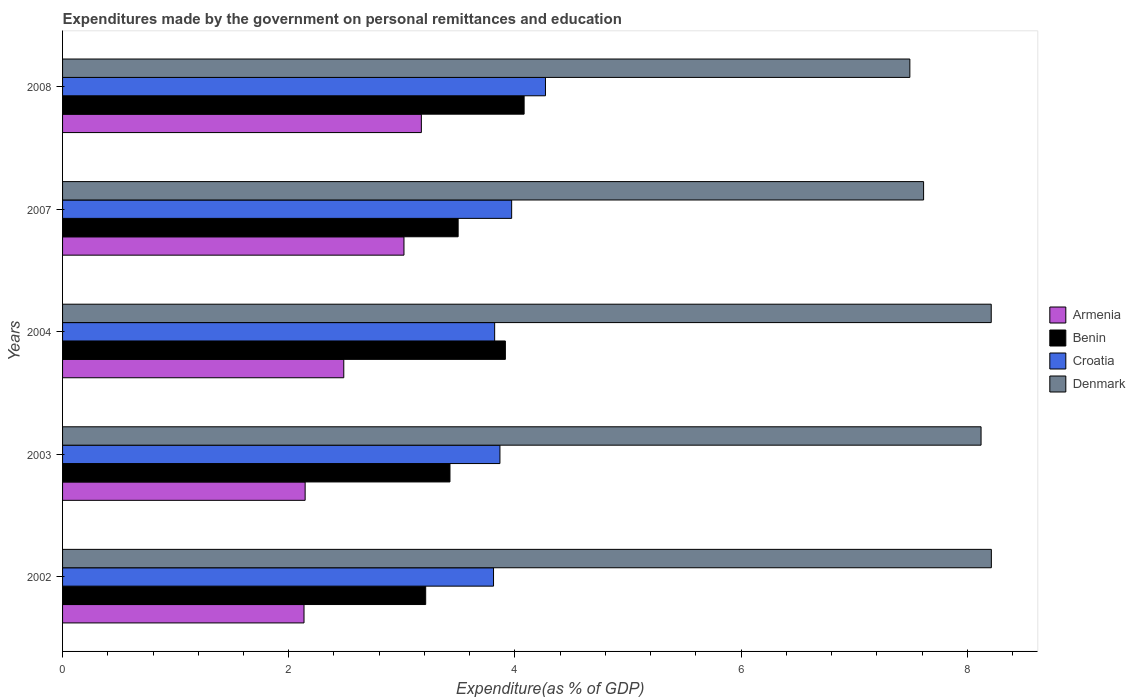How many different coloured bars are there?
Provide a succinct answer. 4. How many bars are there on the 5th tick from the top?
Ensure brevity in your answer.  4. What is the label of the 1st group of bars from the top?
Ensure brevity in your answer.  2008. In how many cases, is the number of bars for a given year not equal to the number of legend labels?
Your answer should be very brief. 0. What is the expenditures made by the government on personal remittances and education in Denmark in 2002?
Provide a short and direct response. 8.21. Across all years, what is the maximum expenditures made by the government on personal remittances and education in Armenia?
Offer a very short reply. 3.17. Across all years, what is the minimum expenditures made by the government on personal remittances and education in Denmark?
Provide a succinct answer. 7.49. In which year was the expenditures made by the government on personal remittances and education in Armenia maximum?
Offer a terse response. 2008. What is the total expenditures made by the government on personal remittances and education in Croatia in the graph?
Your answer should be compact. 19.74. What is the difference between the expenditures made by the government on personal remittances and education in Benin in 2002 and that in 2007?
Offer a very short reply. -0.29. What is the difference between the expenditures made by the government on personal remittances and education in Benin in 2007 and the expenditures made by the government on personal remittances and education in Denmark in 2002?
Your answer should be very brief. -4.72. What is the average expenditures made by the government on personal remittances and education in Croatia per year?
Your answer should be compact. 3.95. In the year 2002, what is the difference between the expenditures made by the government on personal remittances and education in Croatia and expenditures made by the government on personal remittances and education in Benin?
Your answer should be compact. 0.6. In how many years, is the expenditures made by the government on personal remittances and education in Denmark greater than 6 %?
Offer a very short reply. 5. What is the ratio of the expenditures made by the government on personal remittances and education in Denmark in 2003 to that in 2008?
Keep it short and to the point. 1.08. Is the difference between the expenditures made by the government on personal remittances and education in Croatia in 2003 and 2008 greater than the difference between the expenditures made by the government on personal remittances and education in Benin in 2003 and 2008?
Offer a terse response. Yes. What is the difference between the highest and the second highest expenditures made by the government on personal remittances and education in Benin?
Your answer should be very brief. 0.17. What is the difference between the highest and the lowest expenditures made by the government on personal remittances and education in Armenia?
Offer a very short reply. 1.04. Is the sum of the expenditures made by the government on personal remittances and education in Denmark in 2003 and 2007 greater than the maximum expenditures made by the government on personal remittances and education in Armenia across all years?
Offer a terse response. Yes. What does the 2nd bar from the top in 2004 represents?
Give a very brief answer. Croatia. What does the 4th bar from the bottom in 2008 represents?
Provide a succinct answer. Denmark. Is it the case that in every year, the sum of the expenditures made by the government on personal remittances and education in Croatia and expenditures made by the government on personal remittances and education in Benin is greater than the expenditures made by the government on personal remittances and education in Armenia?
Ensure brevity in your answer.  Yes. Are all the bars in the graph horizontal?
Provide a succinct answer. Yes. What is the difference between two consecutive major ticks on the X-axis?
Your answer should be compact. 2. Where does the legend appear in the graph?
Keep it short and to the point. Center right. How are the legend labels stacked?
Provide a succinct answer. Vertical. What is the title of the graph?
Your answer should be very brief. Expenditures made by the government on personal remittances and education. What is the label or title of the X-axis?
Your response must be concise. Expenditure(as % of GDP). What is the Expenditure(as % of GDP) of Armenia in 2002?
Ensure brevity in your answer.  2.14. What is the Expenditure(as % of GDP) of Benin in 2002?
Give a very brief answer. 3.21. What is the Expenditure(as % of GDP) of Croatia in 2002?
Give a very brief answer. 3.81. What is the Expenditure(as % of GDP) in Denmark in 2002?
Make the answer very short. 8.21. What is the Expenditure(as % of GDP) in Armenia in 2003?
Your response must be concise. 2.15. What is the Expenditure(as % of GDP) of Benin in 2003?
Offer a very short reply. 3.43. What is the Expenditure(as % of GDP) of Croatia in 2003?
Keep it short and to the point. 3.87. What is the Expenditure(as % of GDP) in Denmark in 2003?
Make the answer very short. 8.12. What is the Expenditure(as % of GDP) of Armenia in 2004?
Offer a very short reply. 2.49. What is the Expenditure(as % of GDP) in Benin in 2004?
Ensure brevity in your answer.  3.92. What is the Expenditure(as % of GDP) in Croatia in 2004?
Offer a terse response. 3.82. What is the Expenditure(as % of GDP) of Denmark in 2004?
Ensure brevity in your answer.  8.21. What is the Expenditure(as % of GDP) in Armenia in 2007?
Your response must be concise. 3.02. What is the Expenditure(as % of GDP) of Benin in 2007?
Give a very brief answer. 3.5. What is the Expenditure(as % of GDP) in Croatia in 2007?
Ensure brevity in your answer.  3.97. What is the Expenditure(as % of GDP) of Denmark in 2007?
Ensure brevity in your answer.  7.61. What is the Expenditure(as % of GDP) of Armenia in 2008?
Make the answer very short. 3.17. What is the Expenditure(as % of GDP) of Benin in 2008?
Your answer should be very brief. 4.08. What is the Expenditure(as % of GDP) in Croatia in 2008?
Give a very brief answer. 4.27. What is the Expenditure(as % of GDP) in Denmark in 2008?
Offer a very short reply. 7.49. Across all years, what is the maximum Expenditure(as % of GDP) in Armenia?
Ensure brevity in your answer.  3.17. Across all years, what is the maximum Expenditure(as % of GDP) of Benin?
Give a very brief answer. 4.08. Across all years, what is the maximum Expenditure(as % of GDP) of Croatia?
Your response must be concise. 4.27. Across all years, what is the maximum Expenditure(as % of GDP) of Denmark?
Provide a short and direct response. 8.21. Across all years, what is the minimum Expenditure(as % of GDP) of Armenia?
Offer a terse response. 2.14. Across all years, what is the minimum Expenditure(as % of GDP) in Benin?
Make the answer very short. 3.21. Across all years, what is the minimum Expenditure(as % of GDP) of Croatia?
Provide a succinct answer. 3.81. Across all years, what is the minimum Expenditure(as % of GDP) of Denmark?
Ensure brevity in your answer.  7.49. What is the total Expenditure(as % of GDP) of Armenia in the graph?
Ensure brevity in your answer.  12.96. What is the total Expenditure(as % of GDP) in Benin in the graph?
Offer a terse response. 18.13. What is the total Expenditure(as % of GDP) of Croatia in the graph?
Give a very brief answer. 19.74. What is the total Expenditure(as % of GDP) in Denmark in the graph?
Keep it short and to the point. 39.65. What is the difference between the Expenditure(as % of GDP) in Armenia in 2002 and that in 2003?
Provide a short and direct response. -0.01. What is the difference between the Expenditure(as % of GDP) in Benin in 2002 and that in 2003?
Your answer should be compact. -0.21. What is the difference between the Expenditure(as % of GDP) in Croatia in 2002 and that in 2003?
Provide a short and direct response. -0.06. What is the difference between the Expenditure(as % of GDP) in Denmark in 2002 and that in 2003?
Offer a terse response. 0.09. What is the difference between the Expenditure(as % of GDP) of Armenia in 2002 and that in 2004?
Make the answer very short. -0.35. What is the difference between the Expenditure(as % of GDP) in Benin in 2002 and that in 2004?
Make the answer very short. -0.7. What is the difference between the Expenditure(as % of GDP) in Croatia in 2002 and that in 2004?
Your answer should be very brief. -0.01. What is the difference between the Expenditure(as % of GDP) of Denmark in 2002 and that in 2004?
Give a very brief answer. 0. What is the difference between the Expenditure(as % of GDP) of Armenia in 2002 and that in 2007?
Offer a very short reply. -0.88. What is the difference between the Expenditure(as % of GDP) of Benin in 2002 and that in 2007?
Provide a short and direct response. -0.29. What is the difference between the Expenditure(as % of GDP) of Croatia in 2002 and that in 2007?
Provide a short and direct response. -0.16. What is the difference between the Expenditure(as % of GDP) of Denmark in 2002 and that in 2007?
Provide a succinct answer. 0.6. What is the difference between the Expenditure(as % of GDP) in Armenia in 2002 and that in 2008?
Give a very brief answer. -1.04. What is the difference between the Expenditure(as % of GDP) of Benin in 2002 and that in 2008?
Offer a terse response. -0.87. What is the difference between the Expenditure(as % of GDP) of Croatia in 2002 and that in 2008?
Ensure brevity in your answer.  -0.46. What is the difference between the Expenditure(as % of GDP) of Denmark in 2002 and that in 2008?
Offer a very short reply. 0.72. What is the difference between the Expenditure(as % of GDP) in Armenia in 2003 and that in 2004?
Your answer should be compact. -0.34. What is the difference between the Expenditure(as % of GDP) of Benin in 2003 and that in 2004?
Make the answer very short. -0.49. What is the difference between the Expenditure(as % of GDP) of Croatia in 2003 and that in 2004?
Give a very brief answer. 0.05. What is the difference between the Expenditure(as % of GDP) in Denmark in 2003 and that in 2004?
Your answer should be very brief. -0.09. What is the difference between the Expenditure(as % of GDP) in Armenia in 2003 and that in 2007?
Give a very brief answer. -0.87. What is the difference between the Expenditure(as % of GDP) of Benin in 2003 and that in 2007?
Give a very brief answer. -0.07. What is the difference between the Expenditure(as % of GDP) of Croatia in 2003 and that in 2007?
Your response must be concise. -0.1. What is the difference between the Expenditure(as % of GDP) of Denmark in 2003 and that in 2007?
Your answer should be very brief. 0.51. What is the difference between the Expenditure(as % of GDP) in Armenia in 2003 and that in 2008?
Your answer should be very brief. -1.03. What is the difference between the Expenditure(as % of GDP) in Benin in 2003 and that in 2008?
Offer a very short reply. -0.66. What is the difference between the Expenditure(as % of GDP) in Croatia in 2003 and that in 2008?
Offer a very short reply. -0.4. What is the difference between the Expenditure(as % of GDP) of Denmark in 2003 and that in 2008?
Your answer should be compact. 0.63. What is the difference between the Expenditure(as % of GDP) of Armenia in 2004 and that in 2007?
Your answer should be very brief. -0.53. What is the difference between the Expenditure(as % of GDP) of Benin in 2004 and that in 2007?
Ensure brevity in your answer.  0.42. What is the difference between the Expenditure(as % of GDP) in Croatia in 2004 and that in 2007?
Offer a very short reply. -0.15. What is the difference between the Expenditure(as % of GDP) of Denmark in 2004 and that in 2007?
Your answer should be very brief. 0.6. What is the difference between the Expenditure(as % of GDP) in Armenia in 2004 and that in 2008?
Offer a very short reply. -0.69. What is the difference between the Expenditure(as % of GDP) of Benin in 2004 and that in 2008?
Provide a short and direct response. -0.17. What is the difference between the Expenditure(as % of GDP) in Croatia in 2004 and that in 2008?
Give a very brief answer. -0.45. What is the difference between the Expenditure(as % of GDP) in Denmark in 2004 and that in 2008?
Provide a succinct answer. 0.72. What is the difference between the Expenditure(as % of GDP) in Armenia in 2007 and that in 2008?
Your answer should be compact. -0.15. What is the difference between the Expenditure(as % of GDP) of Benin in 2007 and that in 2008?
Your answer should be very brief. -0.58. What is the difference between the Expenditure(as % of GDP) in Croatia in 2007 and that in 2008?
Make the answer very short. -0.3. What is the difference between the Expenditure(as % of GDP) of Denmark in 2007 and that in 2008?
Make the answer very short. 0.12. What is the difference between the Expenditure(as % of GDP) in Armenia in 2002 and the Expenditure(as % of GDP) in Benin in 2003?
Offer a terse response. -1.29. What is the difference between the Expenditure(as % of GDP) of Armenia in 2002 and the Expenditure(as % of GDP) of Croatia in 2003?
Give a very brief answer. -1.73. What is the difference between the Expenditure(as % of GDP) in Armenia in 2002 and the Expenditure(as % of GDP) in Denmark in 2003?
Offer a terse response. -5.99. What is the difference between the Expenditure(as % of GDP) in Benin in 2002 and the Expenditure(as % of GDP) in Croatia in 2003?
Your answer should be very brief. -0.66. What is the difference between the Expenditure(as % of GDP) in Benin in 2002 and the Expenditure(as % of GDP) in Denmark in 2003?
Keep it short and to the point. -4.91. What is the difference between the Expenditure(as % of GDP) in Croatia in 2002 and the Expenditure(as % of GDP) in Denmark in 2003?
Your response must be concise. -4.31. What is the difference between the Expenditure(as % of GDP) of Armenia in 2002 and the Expenditure(as % of GDP) of Benin in 2004?
Give a very brief answer. -1.78. What is the difference between the Expenditure(as % of GDP) in Armenia in 2002 and the Expenditure(as % of GDP) in Croatia in 2004?
Keep it short and to the point. -1.69. What is the difference between the Expenditure(as % of GDP) of Armenia in 2002 and the Expenditure(as % of GDP) of Denmark in 2004?
Make the answer very short. -6.08. What is the difference between the Expenditure(as % of GDP) in Benin in 2002 and the Expenditure(as % of GDP) in Croatia in 2004?
Make the answer very short. -0.61. What is the difference between the Expenditure(as % of GDP) in Benin in 2002 and the Expenditure(as % of GDP) in Denmark in 2004?
Your answer should be compact. -5. What is the difference between the Expenditure(as % of GDP) in Croatia in 2002 and the Expenditure(as % of GDP) in Denmark in 2004?
Your response must be concise. -4.4. What is the difference between the Expenditure(as % of GDP) in Armenia in 2002 and the Expenditure(as % of GDP) in Benin in 2007?
Provide a succinct answer. -1.36. What is the difference between the Expenditure(as % of GDP) of Armenia in 2002 and the Expenditure(as % of GDP) of Croatia in 2007?
Your response must be concise. -1.84. What is the difference between the Expenditure(as % of GDP) of Armenia in 2002 and the Expenditure(as % of GDP) of Denmark in 2007?
Make the answer very short. -5.48. What is the difference between the Expenditure(as % of GDP) in Benin in 2002 and the Expenditure(as % of GDP) in Croatia in 2007?
Offer a terse response. -0.76. What is the difference between the Expenditure(as % of GDP) of Benin in 2002 and the Expenditure(as % of GDP) of Denmark in 2007?
Provide a short and direct response. -4.4. What is the difference between the Expenditure(as % of GDP) in Croatia in 2002 and the Expenditure(as % of GDP) in Denmark in 2007?
Ensure brevity in your answer.  -3.8. What is the difference between the Expenditure(as % of GDP) in Armenia in 2002 and the Expenditure(as % of GDP) in Benin in 2008?
Provide a succinct answer. -1.95. What is the difference between the Expenditure(as % of GDP) of Armenia in 2002 and the Expenditure(as % of GDP) of Croatia in 2008?
Offer a terse response. -2.14. What is the difference between the Expenditure(as % of GDP) in Armenia in 2002 and the Expenditure(as % of GDP) in Denmark in 2008?
Offer a terse response. -5.36. What is the difference between the Expenditure(as % of GDP) in Benin in 2002 and the Expenditure(as % of GDP) in Croatia in 2008?
Your response must be concise. -1.06. What is the difference between the Expenditure(as % of GDP) in Benin in 2002 and the Expenditure(as % of GDP) in Denmark in 2008?
Provide a succinct answer. -4.28. What is the difference between the Expenditure(as % of GDP) of Croatia in 2002 and the Expenditure(as % of GDP) of Denmark in 2008?
Your answer should be very brief. -3.68. What is the difference between the Expenditure(as % of GDP) of Armenia in 2003 and the Expenditure(as % of GDP) of Benin in 2004?
Make the answer very short. -1.77. What is the difference between the Expenditure(as % of GDP) of Armenia in 2003 and the Expenditure(as % of GDP) of Croatia in 2004?
Your answer should be compact. -1.68. What is the difference between the Expenditure(as % of GDP) in Armenia in 2003 and the Expenditure(as % of GDP) in Denmark in 2004?
Keep it short and to the point. -6.07. What is the difference between the Expenditure(as % of GDP) of Benin in 2003 and the Expenditure(as % of GDP) of Croatia in 2004?
Provide a short and direct response. -0.4. What is the difference between the Expenditure(as % of GDP) in Benin in 2003 and the Expenditure(as % of GDP) in Denmark in 2004?
Offer a terse response. -4.79. What is the difference between the Expenditure(as % of GDP) in Croatia in 2003 and the Expenditure(as % of GDP) in Denmark in 2004?
Provide a succinct answer. -4.34. What is the difference between the Expenditure(as % of GDP) in Armenia in 2003 and the Expenditure(as % of GDP) in Benin in 2007?
Keep it short and to the point. -1.35. What is the difference between the Expenditure(as % of GDP) in Armenia in 2003 and the Expenditure(as % of GDP) in Croatia in 2007?
Ensure brevity in your answer.  -1.83. What is the difference between the Expenditure(as % of GDP) in Armenia in 2003 and the Expenditure(as % of GDP) in Denmark in 2007?
Keep it short and to the point. -5.47. What is the difference between the Expenditure(as % of GDP) in Benin in 2003 and the Expenditure(as % of GDP) in Croatia in 2007?
Your answer should be compact. -0.55. What is the difference between the Expenditure(as % of GDP) of Benin in 2003 and the Expenditure(as % of GDP) of Denmark in 2007?
Offer a very short reply. -4.19. What is the difference between the Expenditure(as % of GDP) in Croatia in 2003 and the Expenditure(as % of GDP) in Denmark in 2007?
Provide a short and direct response. -3.75. What is the difference between the Expenditure(as % of GDP) in Armenia in 2003 and the Expenditure(as % of GDP) in Benin in 2008?
Keep it short and to the point. -1.94. What is the difference between the Expenditure(as % of GDP) in Armenia in 2003 and the Expenditure(as % of GDP) in Croatia in 2008?
Make the answer very short. -2.13. What is the difference between the Expenditure(as % of GDP) in Armenia in 2003 and the Expenditure(as % of GDP) in Denmark in 2008?
Keep it short and to the point. -5.35. What is the difference between the Expenditure(as % of GDP) in Benin in 2003 and the Expenditure(as % of GDP) in Croatia in 2008?
Your response must be concise. -0.84. What is the difference between the Expenditure(as % of GDP) of Benin in 2003 and the Expenditure(as % of GDP) of Denmark in 2008?
Give a very brief answer. -4.07. What is the difference between the Expenditure(as % of GDP) in Croatia in 2003 and the Expenditure(as % of GDP) in Denmark in 2008?
Your answer should be compact. -3.62. What is the difference between the Expenditure(as % of GDP) of Armenia in 2004 and the Expenditure(as % of GDP) of Benin in 2007?
Give a very brief answer. -1.01. What is the difference between the Expenditure(as % of GDP) of Armenia in 2004 and the Expenditure(as % of GDP) of Croatia in 2007?
Ensure brevity in your answer.  -1.48. What is the difference between the Expenditure(as % of GDP) of Armenia in 2004 and the Expenditure(as % of GDP) of Denmark in 2007?
Provide a succinct answer. -5.13. What is the difference between the Expenditure(as % of GDP) in Benin in 2004 and the Expenditure(as % of GDP) in Croatia in 2007?
Keep it short and to the point. -0.06. What is the difference between the Expenditure(as % of GDP) of Benin in 2004 and the Expenditure(as % of GDP) of Denmark in 2007?
Make the answer very short. -3.7. What is the difference between the Expenditure(as % of GDP) in Croatia in 2004 and the Expenditure(as % of GDP) in Denmark in 2007?
Provide a succinct answer. -3.79. What is the difference between the Expenditure(as % of GDP) in Armenia in 2004 and the Expenditure(as % of GDP) in Benin in 2008?
Provide a short and direct response. -1.59. What is the difference between the Expenditure(as % of GDP) of Armenia in 2004 and the Expenditure(as % of GDP) of Croatia in 2008?
Make the answer very short. -1.78. What is the difference between the Expenditure(as % of GDP) of Armenia in 2004 and the Expenditure(as % of GDP) of Denmark in 2008?
Give a very brief answer. -5.01. What is the difference between the Expenditure(as % of GDP) of Benin in 2004 and the Expenditure(as % of GDP) of Croatia in 2008?
Provide a succinct answer. -0.35. What is the difference between the Expenditure(as % of GDP) of Benin in 2004 and the Expenditure(as % of GDP) of Denmark in 2008?
Give a very brief answer. -3.58. What is the difference between the Expenditure(as % of GDP) in Croatia in 2004 and the Expenditure(as % of GDP) in Denmark in 2008?
Your answer should be compact. -3.67. What is the difference between the Expenditure(as % of GDP) of Armenia in 2007 and the Expenditure(as % of GDP) of Benin in 2008?
Provide a short and direct response. -1.06. What is the difference between the Expenditure(as % of GDP) of Armenia in 2007 and the Expenditure(as % of GDP) of Croatia in 2008?
Provide a succinct answer. -1.25. What is the difference between the Expenditure(as % of GDP) of Armenia in 2007 and the Expenditure(as % of GDP) of Denmark in 2008?
Offer a very short reply. -4.47. What is the difference between the Expenditure(as % of GDP) of Benin in 2007 and the Expenditure(as % of GDP) of Croatia in 2008?
Offer a very short reply. -0.77. What is the difference between the Expenditure(as % of GDP) in Benin in 2007 and the Expenditure(as % of GDP) in Denmark in 2008?
Offer a terse response. -3.99. What is the difference between the Expenditure(as % of GDP) in Croatia in 2007 and the Expenditure(as % of GDP) in Denmark in 2008?
Offer a terse response. -3.52. What is the average Expenditure(as % of GDP) in Armenia per year?
Your answer should be compact. 2.59. What is the average Expenditure(as % of GDP) of Benin per year?
Make the answer very short. 3.63. What is the average Expenditure(as % of GDP) of Croatia per year?
Provide a succinct answer. 3.95. What is the average Expenditure(as % of GDP) of Denmark per year?
Your answer should be very brief. 7.93. In the year 2002, what is the difference between the Expenditure(as % of GDP) of Armenia and Expenditure(as % of GDP) of Benin?
Offer a very short reply. -1.08. In the year 2002, what is the difference between the Expenditure(as % of GDP) in Armenia and Expenditure(as % of GDP) in Croatia?
Offer a terse response. -1.68. In the year 2002, what is the difference between the Expenditure(as % of GDP) in Armenia and Expenditure(as % of GDP) in Denmark?
Your response must be concise. -6.08. In the year 2002, what is the difference between the Expenditure(as % of GDP) of Benin and Expenditure(as % of GDP) of Denmark?
Your response must be concise. -5. In the year 2002, what is the difference between the Expenditure(as % of GDP) in Croatia and Expenditure(as % of GDP) in Denmark?
Give a very brief answer. -4.4. In the year 2003, what is the difference between the Expenditure(as % of GDP) in Armenia and Expenditure(as % of GDP) in Benin?
Your answer should be compact. -1.28. In the year 2003, what is the difference between the Expenditure(as % of GDP) of Armenia and Expenditure(as % of GDP) of Croatia?
Give a very brief answer. -1.72. In the year 2003, what is the difference between the Expenditure(as % of GDP) in Armenia and Expenditure(as % of GDP) in Denmark?
Your answer should be compact. -5.98. In the year 2003, what is the difference between the Expenditure(as % of GDP) of Benin and Expenditure(as % of GDP) of Croatia?
Offer a terse response. -0.44. In the year 2003, what is the difference between the Expenditure(as % of GDP) in Benin and Expenditure(as % of GDP) in Denmark?
Offer a very short reply. -4.7. In the year 2003, what is the difference between the Expenditure(as % of GDP) of Croatia and Expenditure(as % of GDP) of Denmark?
Your answer should be very brief. -4.25. In the year 2004, what is the difference between the Expenditure(as % of GDP) of Armenia and Expenditure(as % of GDP) of Benin?
Provide a short and direct response. -1.43. In the year 2004, what is the difference between the Expenditure(as % of GDP) of Armenia and Expenditure(as % of GDP) of Croatia?
Provide a succinct answer. -1.33. In the year 2004, what is the difference between the Expenditure(as % of GDP) of Armenia and Expenditure(as % of GDP) of Denmark?
Give a very brief answer. -5.73. In the year 2004, what is the difference between the Expenditure(as % of GDP) of Benin and Expenditure(as % of GDP) of Croatia?
Provide a short and direct response. 0.09. In the year 2004, what is the difference between the Expenditure(as % of GDP) of Benin and Expenditure(as % of GDP) of Denmark?
Offer a very short reply. -4.3. In the year 2004, what is the difference between the Expenditure(as % of GDP) in Croatia and Expenditure(as % of GDP) in Denmark?
Keep it short and to the point. -4.39. In the year 2007, what is the difference between the Expenditure(as % of GDP) of Armenia and Expenditure(as % of GDP) of Benin?
Give a very brief answer. -0.48. In the year 2007, what is the difference between the Expenditure(as % of GDP) of Armenia and Expenditure(as % of GDP) of Croatia?
Provide a short and direct response. -0.95. In the year 2007, what is the difference between the Expenditure(as % of GDP) of Armenia and Expenditure(as % of GDP) of Denmark?
Your response must be concise. -4.59. In the year 2007, what is the difference between the Expenditure(as % of GDP) of Benin and Expenditure(as % of GDP) of Croatia?
Ensure brevity in your answer.  -0.47. In the year 2007, what is the difference between the Expenditure(as % of GDP) in Benin and Expenditure(as % of GDP) in Denmark?
Your answer should be compact. -4.12. In the year 2007, what is the difference between the Expenditure(as % of GDP) of Croatia and Expenditure(as % of GDP) of Denmark?
Make the answer very short. -3.64. In the year 2008, what is the difference between the Expenditure(as % of GDP) in Armenia and Expenditure(as % of GDP) in Benin?
Provide a succinct answer. -0.91. In the year 2008, what is the difference between the Expenditure(as % of GDP) of Armenia and Expenditure(as % of GDP) of Croatia?
Keep it short and to the point. -1.1. In the year 2008, what is the difference between the Expenditure(as % of GDP) of Armenia and Expenditure(as % of GDP) of Denmark?
Give a very brief answer. -4.32. In the year 2008, what is the difference between the Expenditure(as % of GDP) of Benin and Expenditure(as % of GDP) of Croatia?
Your response must be concise. -0.19. In the year 2008, what is the difference between the Expenditure(as % of GDP) in Benin and Expenditure(as % of GDP) in Denmark?
Make the answer very short. -3.41. In the year 2008, what is the difference between the Expenditure(as % of GDP) of Croatia and Expenditure(as % of GDP) of Denmark?
Provide a succinct answer. -3.22. What is the ratio of the Expenditure(as % of GDP) of Armenia in 2002 to that in 2003?
Your answer should be compact. 1. What is the ratio of the Expenditure(as % of GDP) in Benin in 2002 to that in 2003?
Provide a short and direct response. 0.94. What is the ratio of the Expenditure(as % of GDP) in Croatia in 2002 to that in 2003?
Your answer should be very brief. 0.99. What is the ratio of the Expenditure(as % of GDP) of Denmark in 2002 to that in 2003?
Your answer should be very brief. 1.01. What is the ratio of the Expenditure(as % of GDP) in Armenia in 2002 to that in 2004?
Your answer should be compact. 0.86. What is the ratio of the Expenditure(as % of GDP) in Benin in 2002 to that in 2004?
Your answer should be very brief. 0.82. What is the ratio of the Expenditure(as % of GDP) of Denmark in 2002 to that in 2004?
Keep it short and to the point. 1. What is the ratio of the Expenditure(as % of GDP) of Armenia in 2002 to that in 2007?
Your response must be concise. 0.71. What is the ratio of the Expenditure(as % of GDP) of Benin in 2002 to that in 2007?
Provide a succinct answer. 0.92. What is the ratio of the Expenditure(as % of GDP) of Croatia in 2002 to that in 2007?
Provide a succinct answer. 0.96. What is the ratio of the Expenditure(as % of GDP) in Denmark in 2002 to that in 2007?
Keep it short and to the point. 1.08. What is the ratio of the Expenditure(as % of GDP) of Armenia in 2002 to that in 2008?
Provide a succinct answer. 0.67. What is the ratio of the Expenditure(as % of GDP) in Benin in 2002 to that in 2008?
Offer a terse response. 0.79. What is the ratio of the Expenditure(as % of GDP) of Croatia in 2002 to that in 2008?
Keep it short and to the point. 0.89. What is the ratio of the Expenditure(as % of GDP) in Denmark in 2002 to that in 2008?
Make the answer very short. 1.1. What is the ratio of the Expenditure(as % of GDP) of Armenia in 2003 to that in 2004?
Make the answer very short. 0.86. What is the ratio of the Expenditure(as % of GDP) in Benin in 2003 to that in 2004?
Provide a short and direct response. 0.87. What is the ratio of the Expenditure(as % of GDP) of Croatia in 2003 to that in 2004?
Provide a short and direct response. 1.01. What is the ratio of the Expenditure(as % of GDP) of Armenia in 2003 to that in 2007?
Your answer should be very brief. 0.71. What is the ratio of the Expenditure(as % of GDP) of Benin in 2003 to that in 2007?
Offer a very short reply. 0.98. What is the ratio of the Expenditure(as % of GDP) of Croatia in 2003 to that in 2007?
Your response must be concise. 0.97. What is the ratio of the Expenditure(as % of GDP) in Denmark in 2003 to that in 2007?
Provide a succinct answer. 1.07. What is the ratio of the Expenditure(as % of GDP) in Armenia in 2003 to that in 2008?
Provide a short and direct response. 0.68. What is the ratio of the Expenditure(as % of GDP) in Benin in 2003 to that in 2008?
Offer a very short reply. 0.84. What is the ratio of the Expenditure(as % of GDP) of Croatia in 2003 to that in 2008?
Offer a terse response. 0.91. What is the ratio of the Expenditure(as % of GDP) in Denmark in 2003 to that in 2008?
Provide a short and direct response. 1.08. What is the ratio of the Expenditure(as % of GDP) in Armenia in 2004 to that in 2007?
Provide a succinct answer. 0.82. What is the ratio of the Expenditure(as % of GDP) in Benin in 2004 to that in 2007?
Offer a terse response. 1.12. What is the ratio of the Expenditure(as % of GDP) of Croatia in 2004 to that in 2007?
Give a very brief answer. 0.96. What is the ratio of the Expenditure(as % of GDP) in Denmark in 2004 to that in 2007?
Offer a very short reply. 1.08. What is the ratio of the Expenditure(as % of GDP) in Armenia in 2004 to that in 2008?
Make the answer very short. 0.78. What is the ratio of the Expenditure(as % of GDP) of Benin in 2004 to that in 2008?
Your answer should be compact. 0.96. What is the ratio of the Expenditure(as % of GDP) of Croatia in 2004 to that in 2008?
Give a very brief answer. 0.89. What is the ratio of the Expenditure(as % of GDP) in Denmark in 2004 to that in 2008?
Ensure brevity in your answer.  1.1. What is the ratio of the Expenditure(as % of GDP) of Armenia in 2007 to that in 2008?
Ensure brevity in your answer.  0.95. What is the ratio of the Expenditure(as % of GDP) in Denmark in 2007 to that in 2008?
Ensure brevity in your answer.  1.02. What is the difference between the highest and the second highest Expenditure(as % of GDP) in Armenia?
Provide a succinct answer. 0.15. What is the difference between the highest and the second highest Expenditure(as % of GDP) of Benin?
Your response must be concise. 0.17. What is the difference between the highest and the second highest Expenditure(as % of GDP) in Croatia?
Offer a very short reply. 0.3. What is the difference between the highest and the second highest Expenditure(as % of GDP) in Denmark?
Your answer should be compact. 0. What is the difference between the highest and the lowest Expenditure(as % of GDP) in Armenia?
Offer a terse response. 1.04. What is the difference between the highest and the lowest Expenditure(as % of GDP) in Benin?
Provide a succinct answer. 0.87. What is the difference between the highest and the lowest Expenditure(as % of GDP) of Croatia?
Your answer should be very brief. 0.46. What is the difference between the highest and the lowest Expenditure(as % of GDP) of Denmark?
Provide a succinct answer. 0.72. 